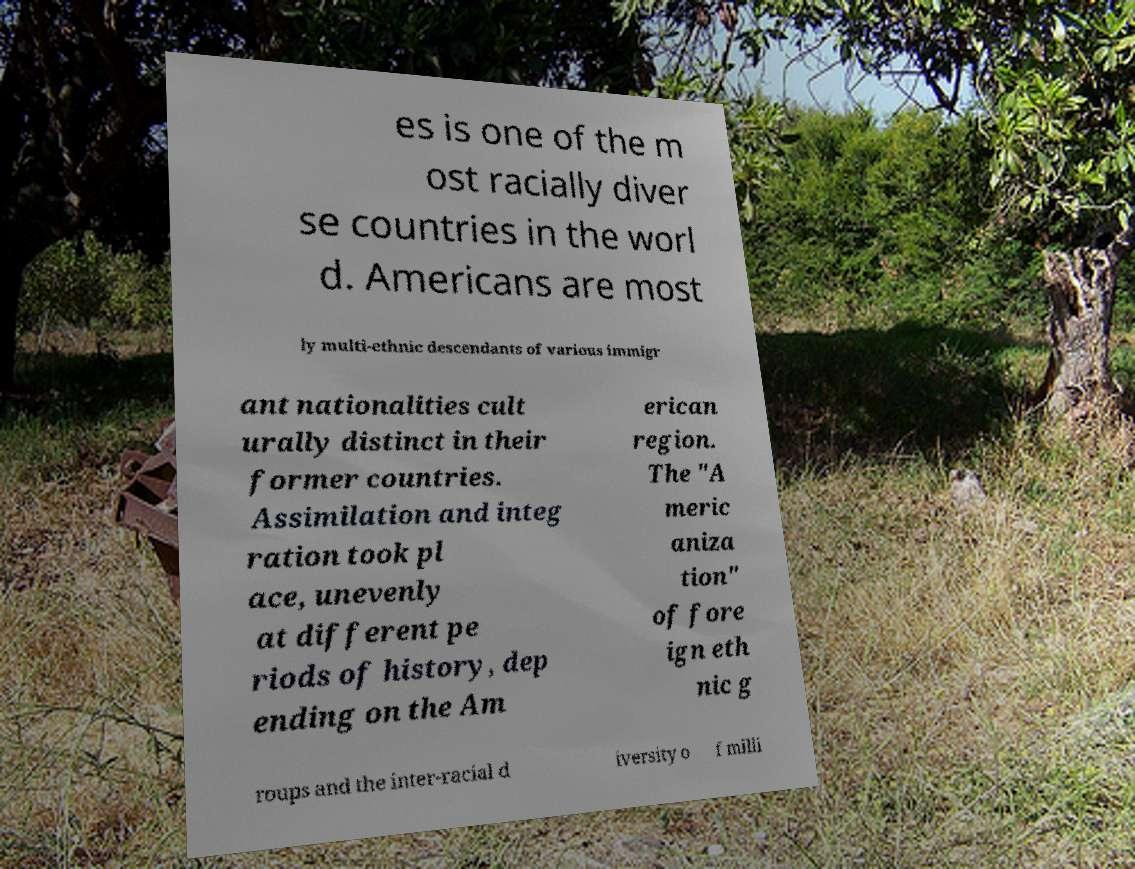Please identify and transcribe the text found in this image. es is one of the m ost racially diver se countries in the worl d. Americans are most ly multi-ethnic descendants of various immigr ant nationalities cult urally distinct in their former countries. Assimilation and integ ration took pl ace, unevenly at different pe riods of history, dep ending on the Am erican region. The "A meric aniza tion" of fore ign eth nic g roups and the inter-racial d iversity o f milli 